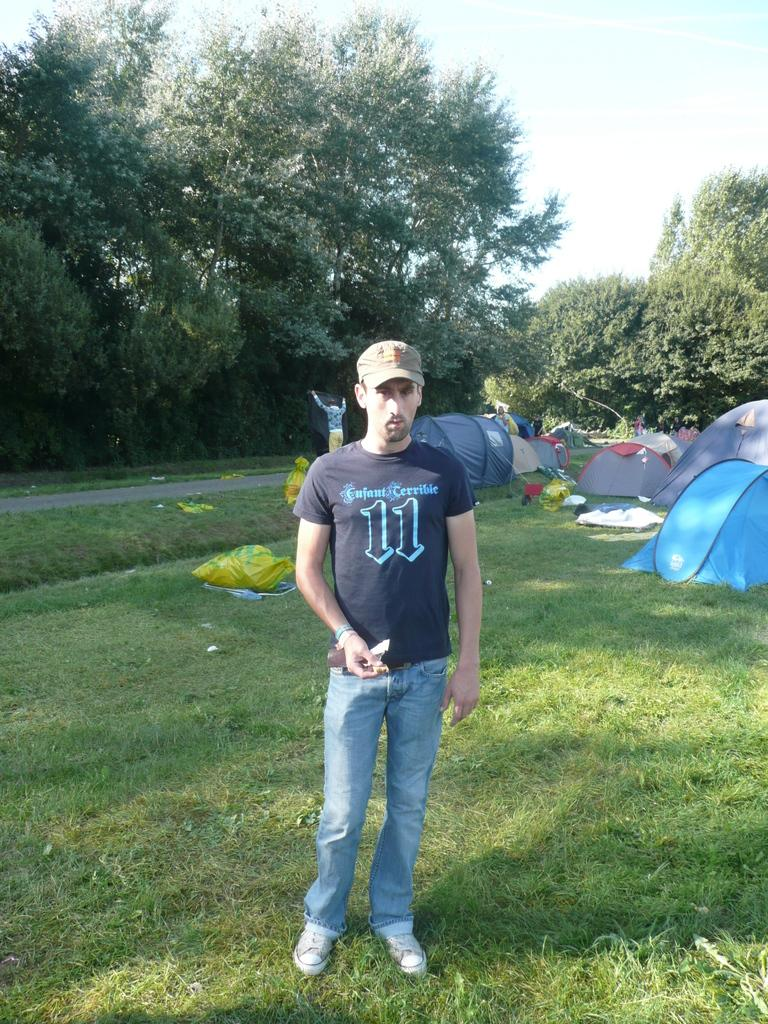What is the main subject of the image? There is a person standing in the center of the image. Where is the person standing? The person is standing on the grass. What can be seen in the background of the image? There are trees, tents, and a road in the background of the image. What type of linen is being used to cover the tooth in the image? There is no linen or tooth present in the image. 